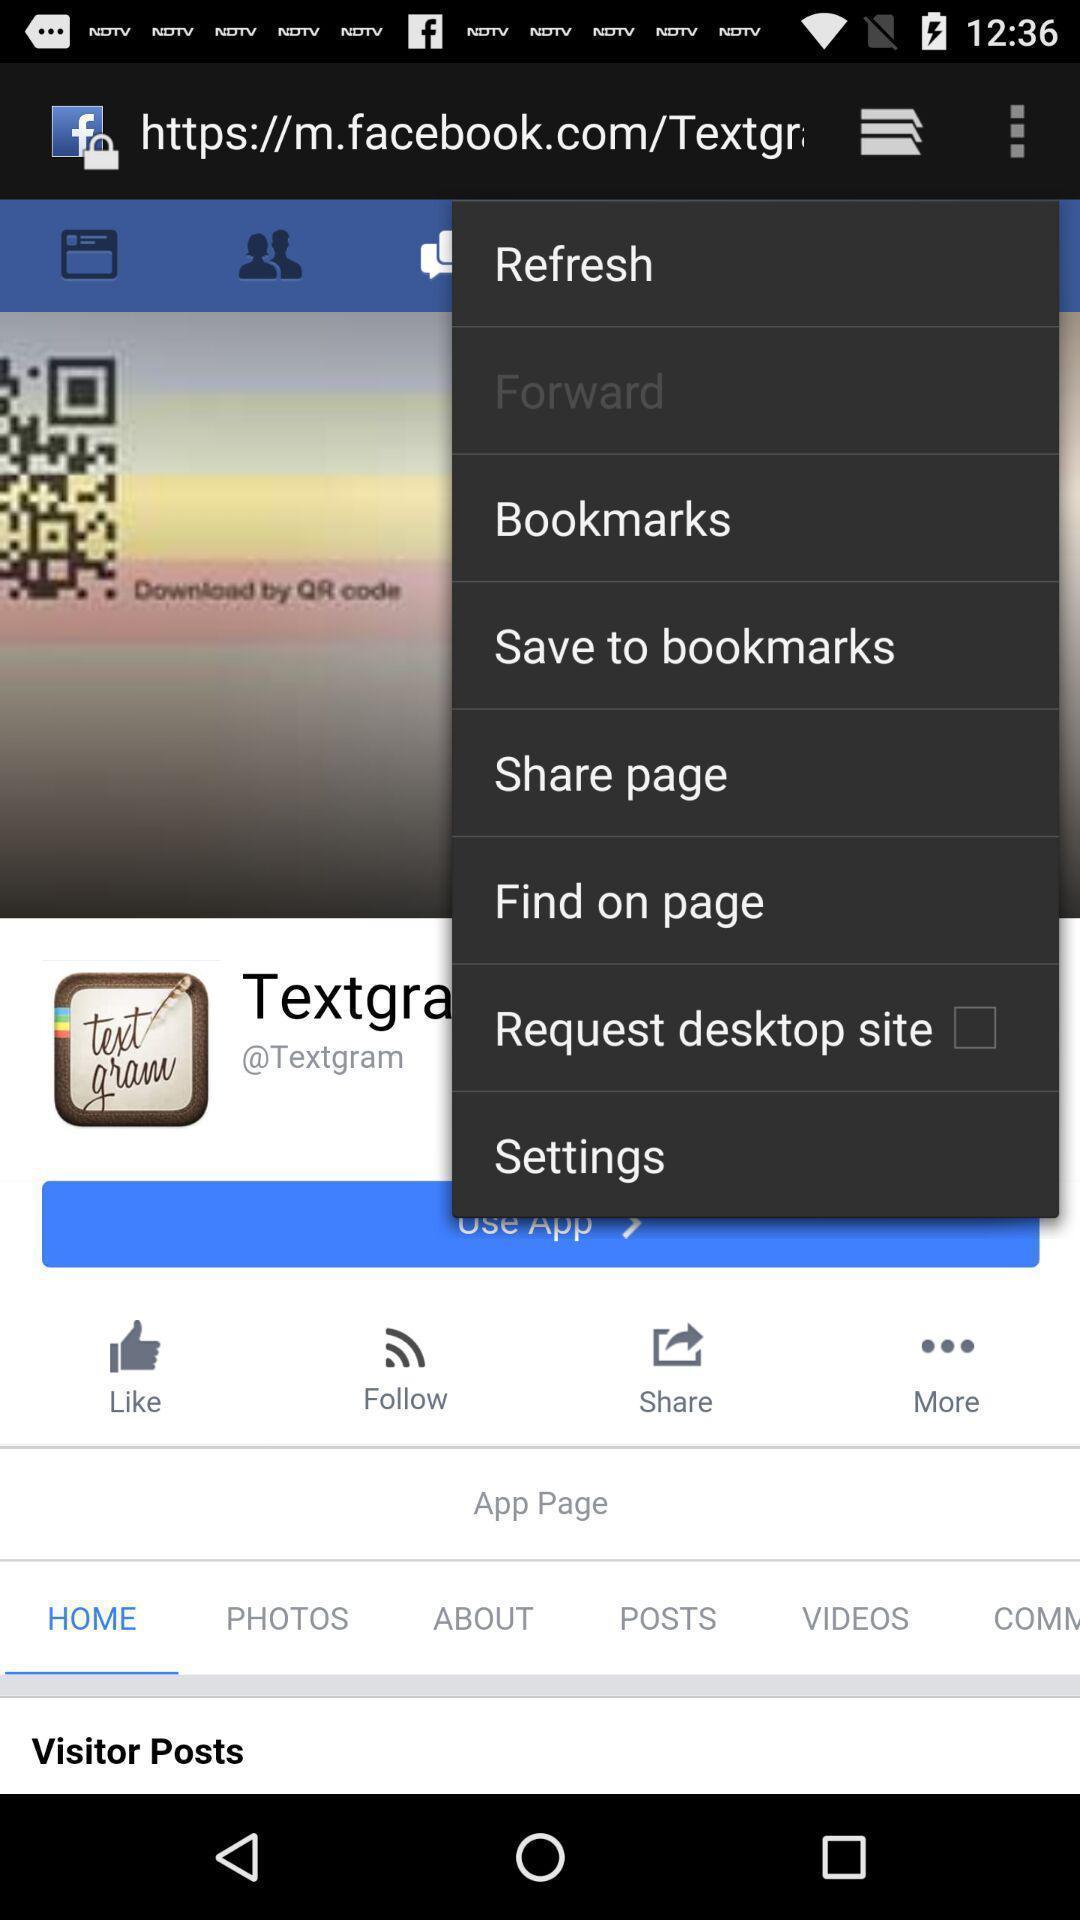Provide a detailed account of this screenshot. Various options in social media app. 